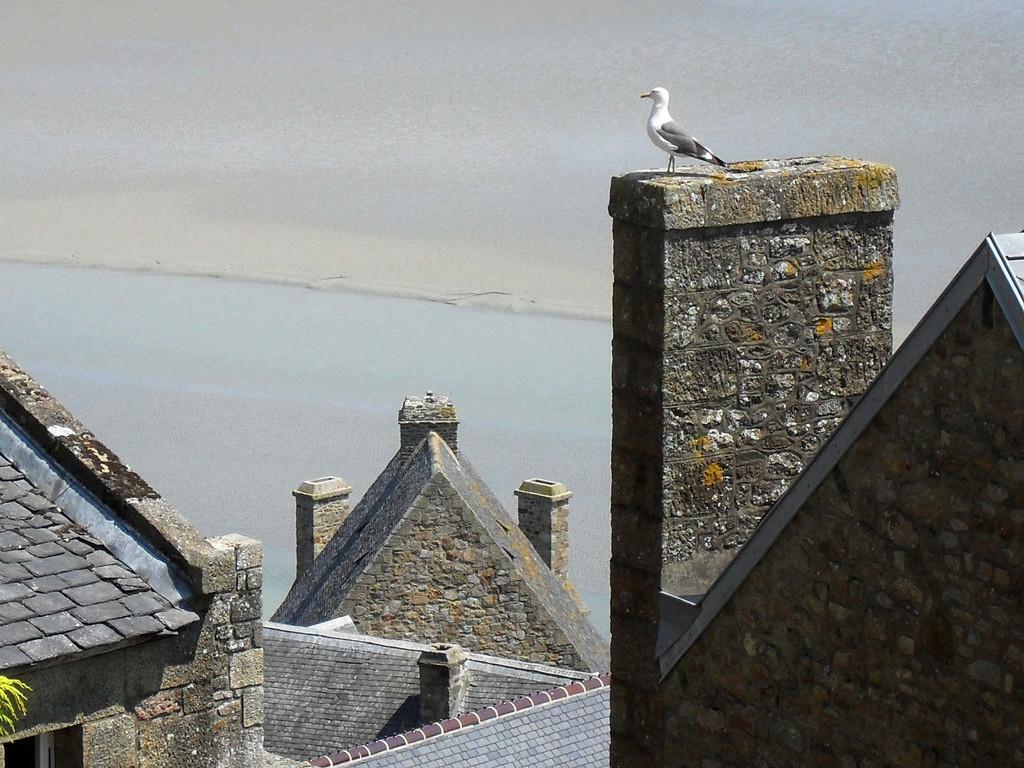Please provide a concise description of this image. In this image in the front there are buildings. On the left side there are leaves and there is a bird on the top of the building. In the background there is water and the sky is cloudy. 